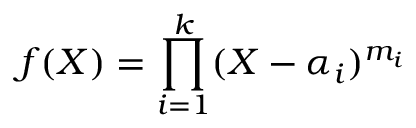Convert formula to latex. <formula><loc_0><loc_0><loc_500><loc_500>f ( X ) = \prod _ { i = 1 } ^ { k } ( X - \alpha _ { i } ) ^ { m _ { i } }</formula> 